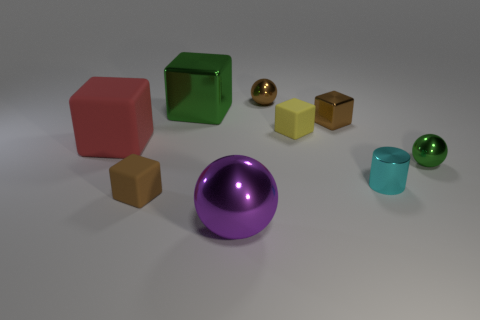Subtract all green balls. Subtract all gray blocks. How many balls are left? 2 Subtract all cyan cylinders. How many red blocks are left? 1 Subtract all green spheres. How many spheres are left? 2 Subtract all big spheres. How many spheres are left? 2 Subtract all small green metal balls. Subtract all shiny spheres. How many objects are left? 5 Add 3 tiny yellow cubes. How many tiny yellow cubes are left? 4 Add 4 purple things. How many purple things exist? 5 Subtract 1 green blocks. How many objects are left? 8 Subtract all cylinders. How many objects are left? 8 Subtract 4 blocks. How many blocks are left? 1 